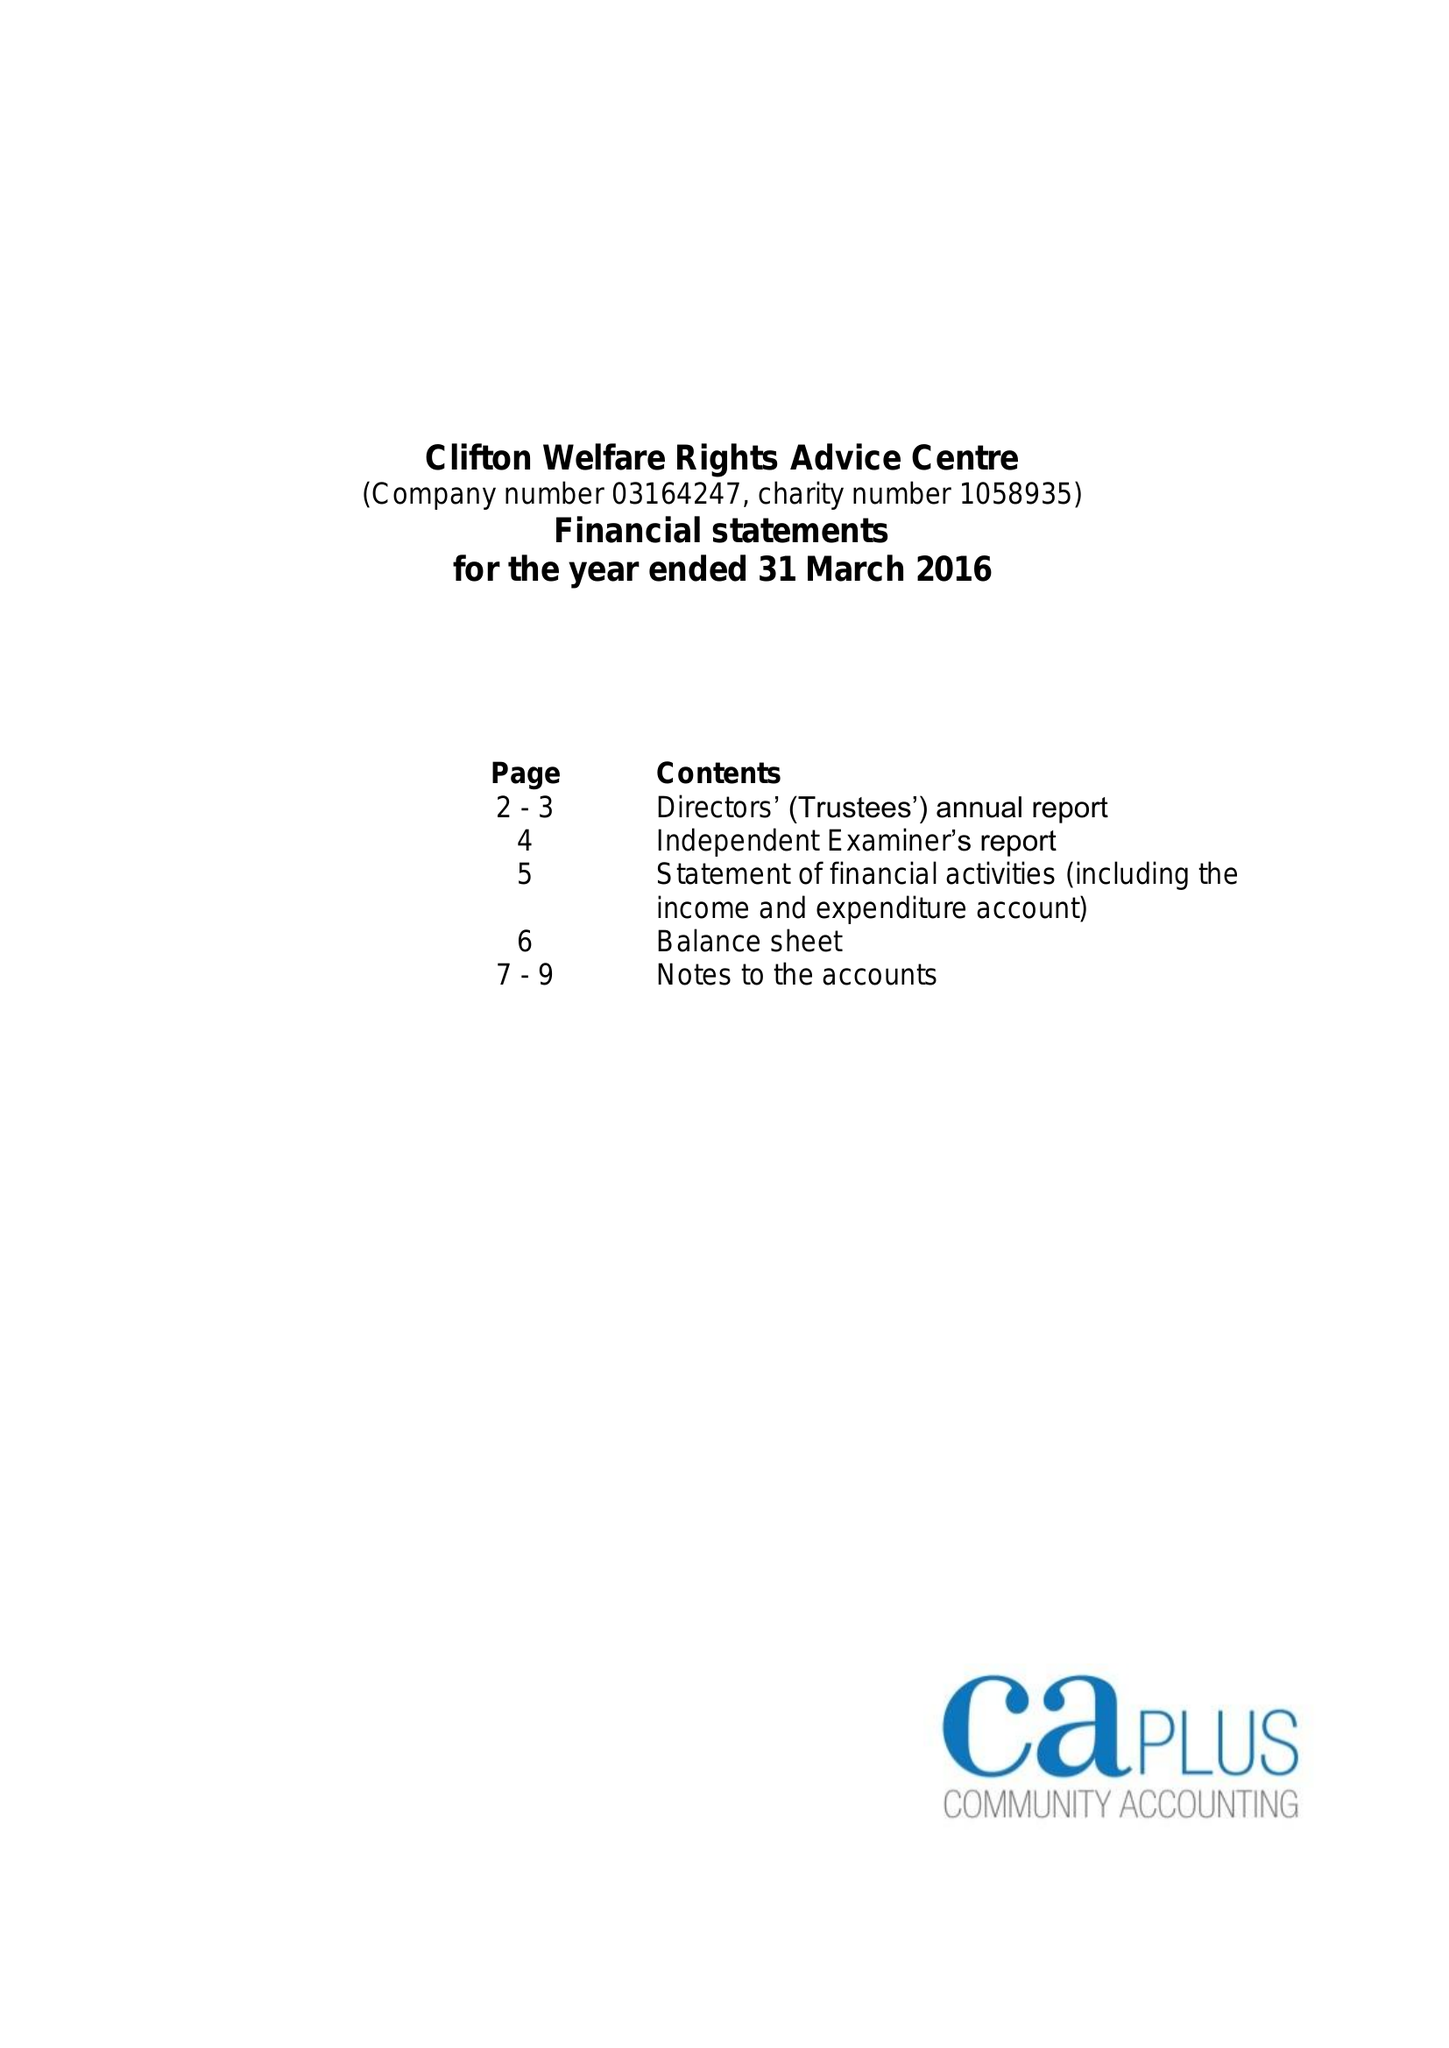What is the value for the charity_number?
Answer the question using a single word or phrase. 1058935 